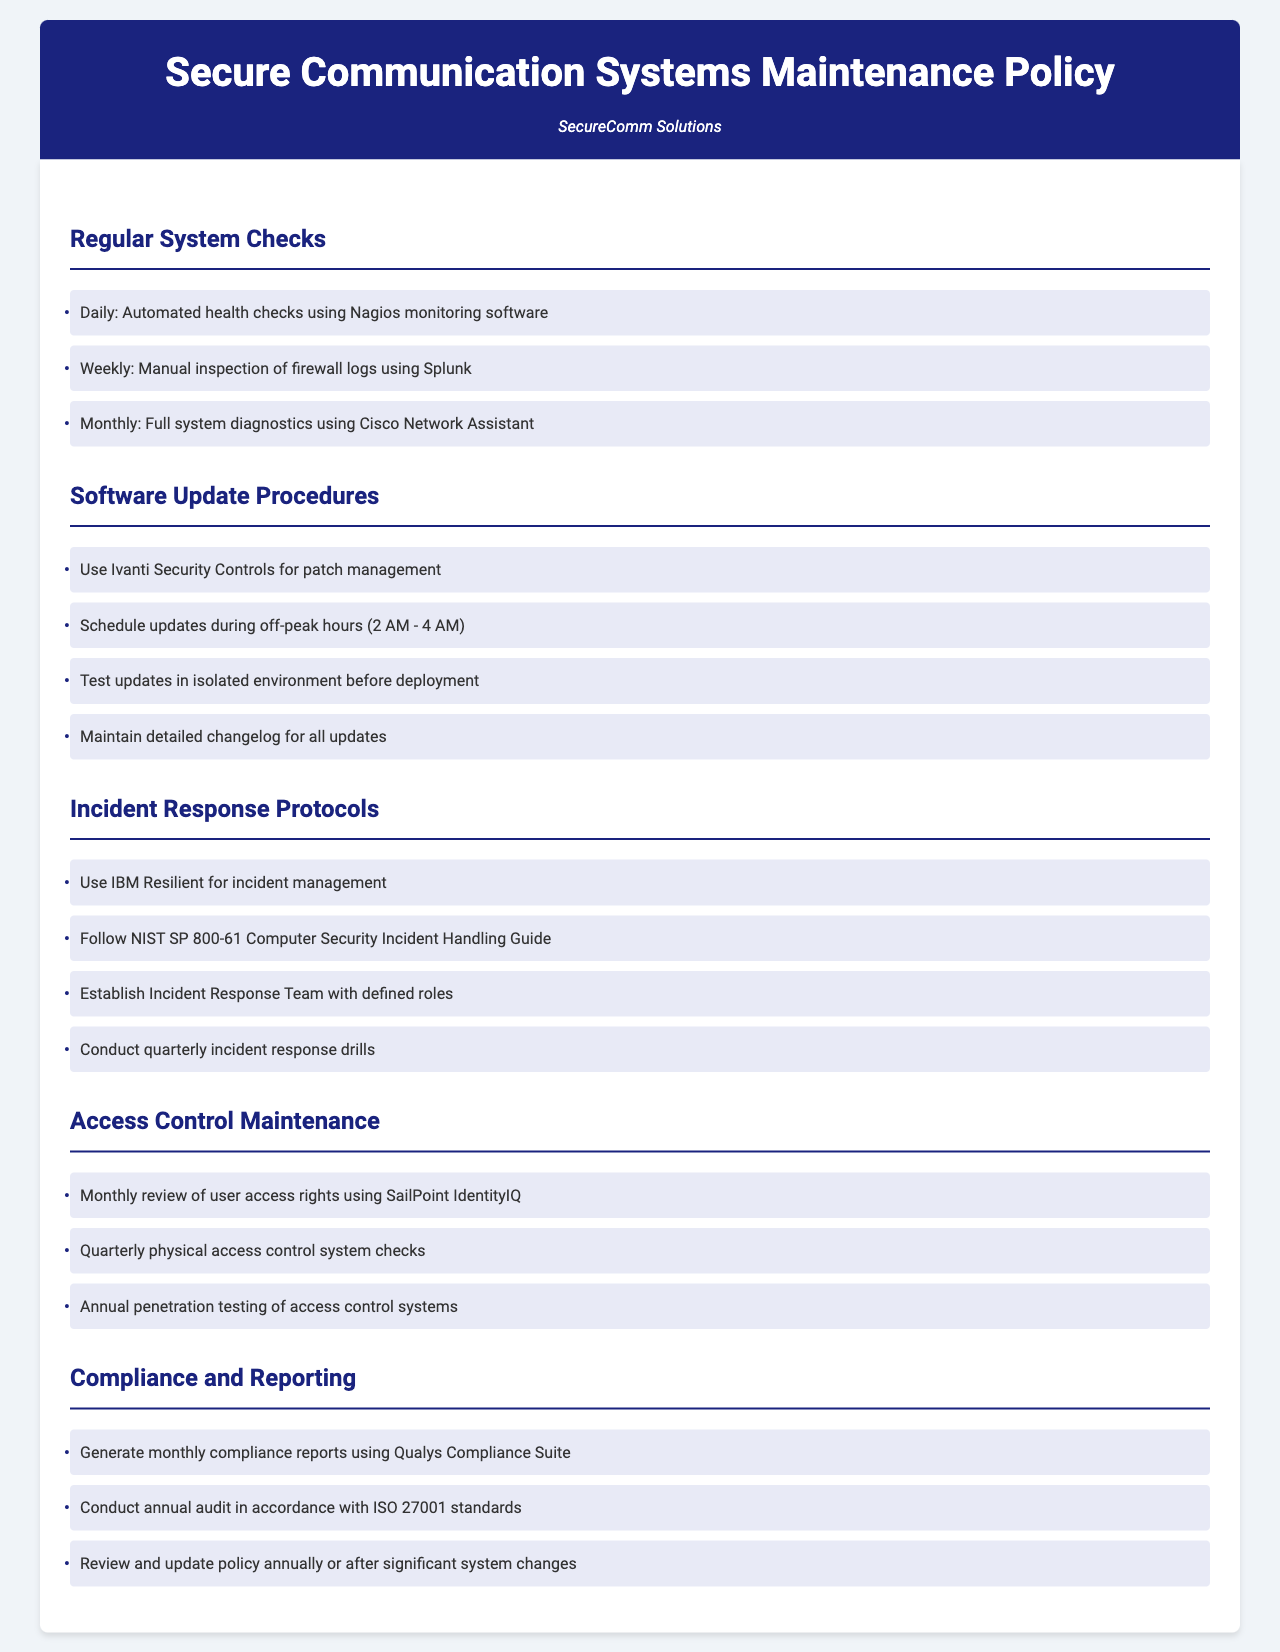What is the monitoring software used for daily checks? The document states that Nagios monitoring software is used for daily health checks of the system.
Answer: Nagios What is the time frame scheduled for software updates? The policy specifies that software updates are scheduled during off-peak hours from 2 AM to 4 AM.
Answer: 2 AM - 4 AM Which tool is used for incident management? The document indicates that IBM Resilient is utilized for incident management purposes.
Answer: IBM Resilient How often are full system diagnostics conducted? According to the document, full system diagnostics are conducted on a monthly basis.
Answer: Monthly What guide is followed for incident response? The policy mentions that the NIST SP 800-61 Computer Security Incident Handling Guide is followed for incident response.
Answer: NIST SP 800-61 What is reviewed monthly related to access control? The document states that a monthly review of user access rights is conducted.
Answer: User access rights How frequently are incident response drills conducted? The policy specifies that incident response drills are conducted on a quarterly basis.
Answer: Quarterly What is the annual audit standard mentioned? The document indicates that the annual audit is conducted in accordance with ISO 27001 standards.
Answer: ISO 27001 Which software is used for patch management? The policy states that Ivanti Security Controls is used for patch management tasks.
Answer: Ivanti Security Controls What type of testing is performed annually on access control systems? The document indicates that an annual penetration testing is performed on the access control systems.
Answer: Penetration testing 